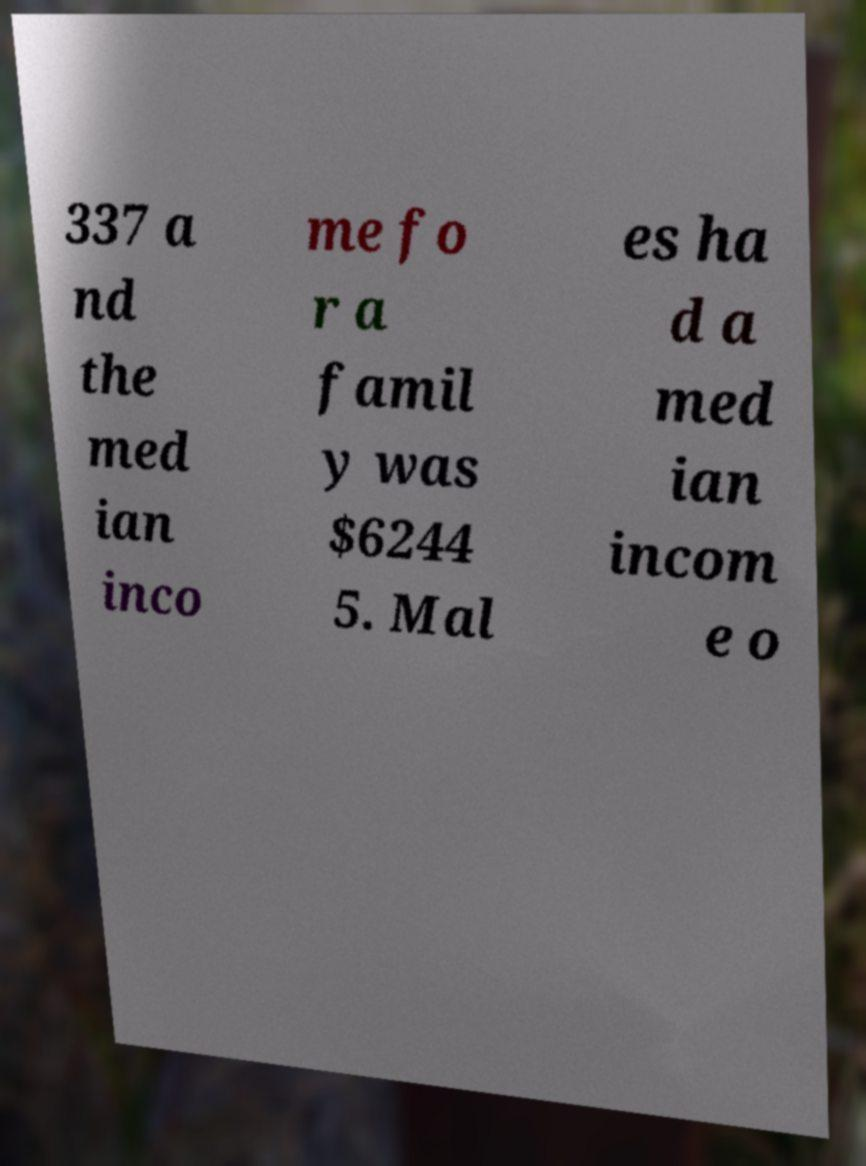For documentation purposes, I need the text within this image transcribed. Could you provide that? 337 a nd the med ian inco me fo r a famil y was $6244 5. Mal es ha d a med ian incom e o 